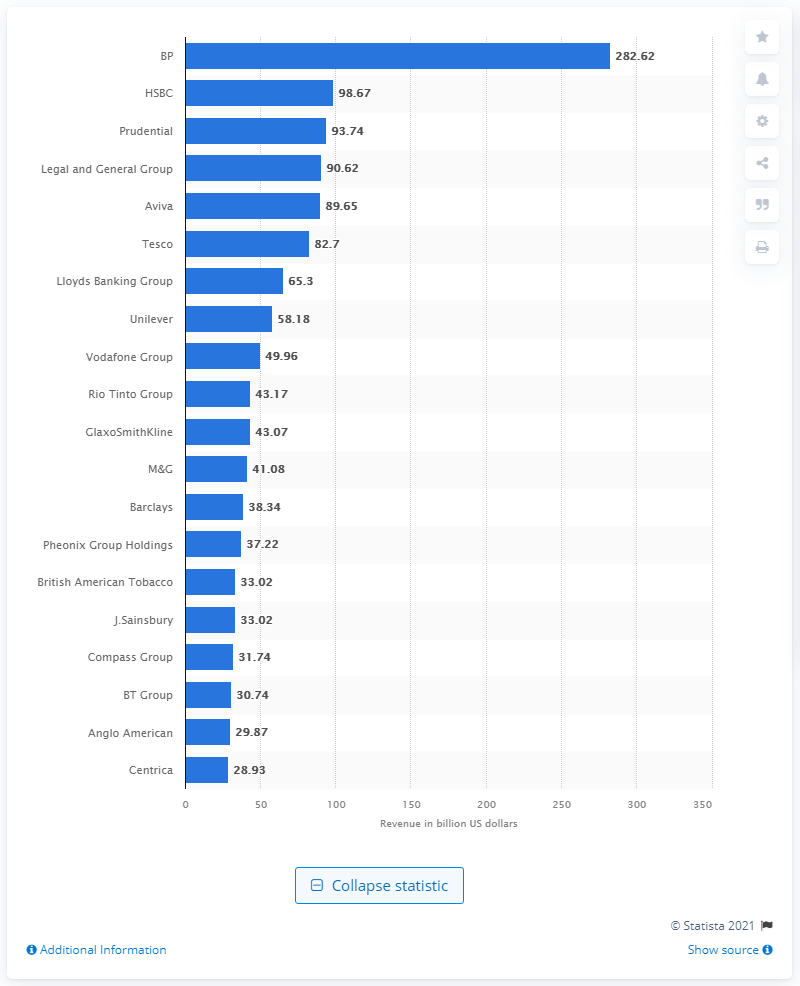Outline some significant characteristics in this image. HSBC, a British bank, was the second-highest revenue generating bank in the United Kingdom in 2020. BP's annual revenue in the United States in 2020 was approximately $282.62 million. Prudential's annual revenue was 93.74 million dollars. 